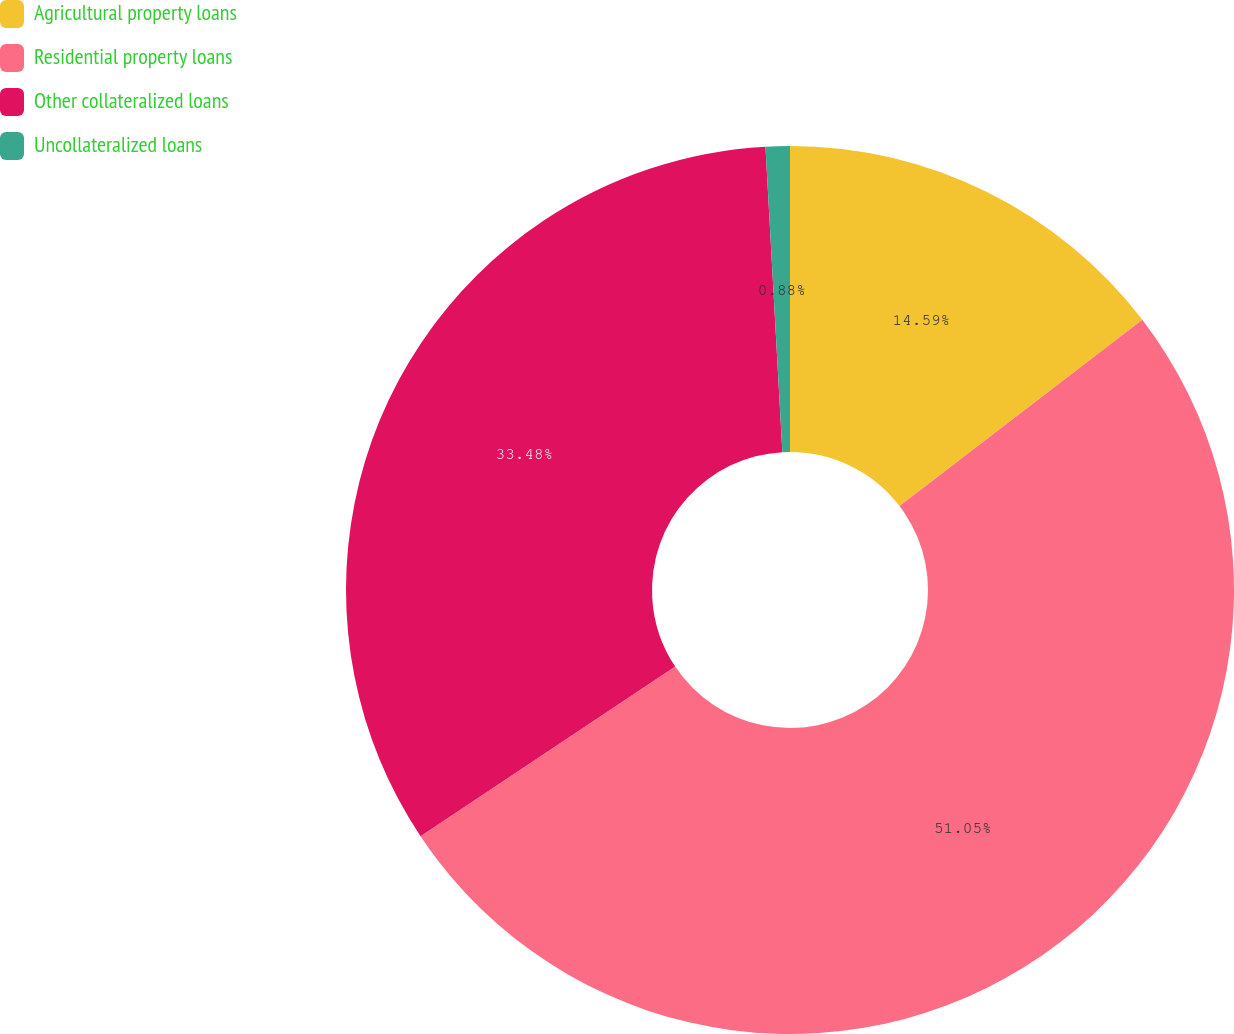<chart> <loc_0><loc_0><loc_500><loc_500><pie_chart><fcel>Agricultural property loans<fcel>Residential property loans<fcel>Other collateralized loans<fcel>Uncollateralized loans<nl><fcel>14.59%<fcel>51.06%<fcel>33.48%<fcel>0.88%<nl></chart> 